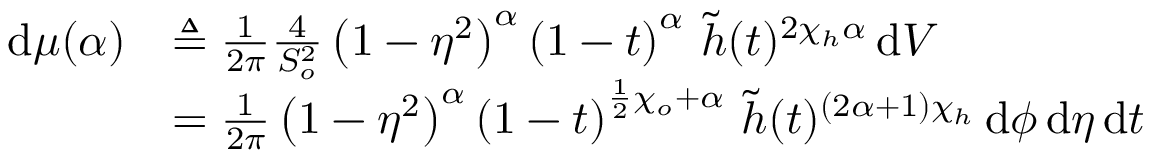<formula> <loc_0><loc_0><loc_500><loc_500>\begin{array} { r l } { \, d \mu ( \alpha ) } & { \triangle q \frac { 1 } { 2 \pi } \frac { 4 } { S _ { o } ^ { 2 } } \left ( 1 - \eta ^ { 2 } \right ) ^ { \alpha } \left ( 1 - t \right ) ^ { \alpha } \, \widetilde { h } ( t ) ^ { 2 \chi _ { h } \alpha } \, d V } \\ & { = \frac { 1 } { 2 \pi } \left ( 1 - \eta ^ { 2 } \right ) ^ { \alpha } \left ( 1 - t \right ) ^ { \frac { 1 } { 2 } \chi _ { o } + \alpha } \, \widetilde { h } ( t ) ^ { \left ( 2 \alpha + 1 \right ) \chi _ { h } } \, d \phi \, d \eta \, d t } \end{array}</formula> 